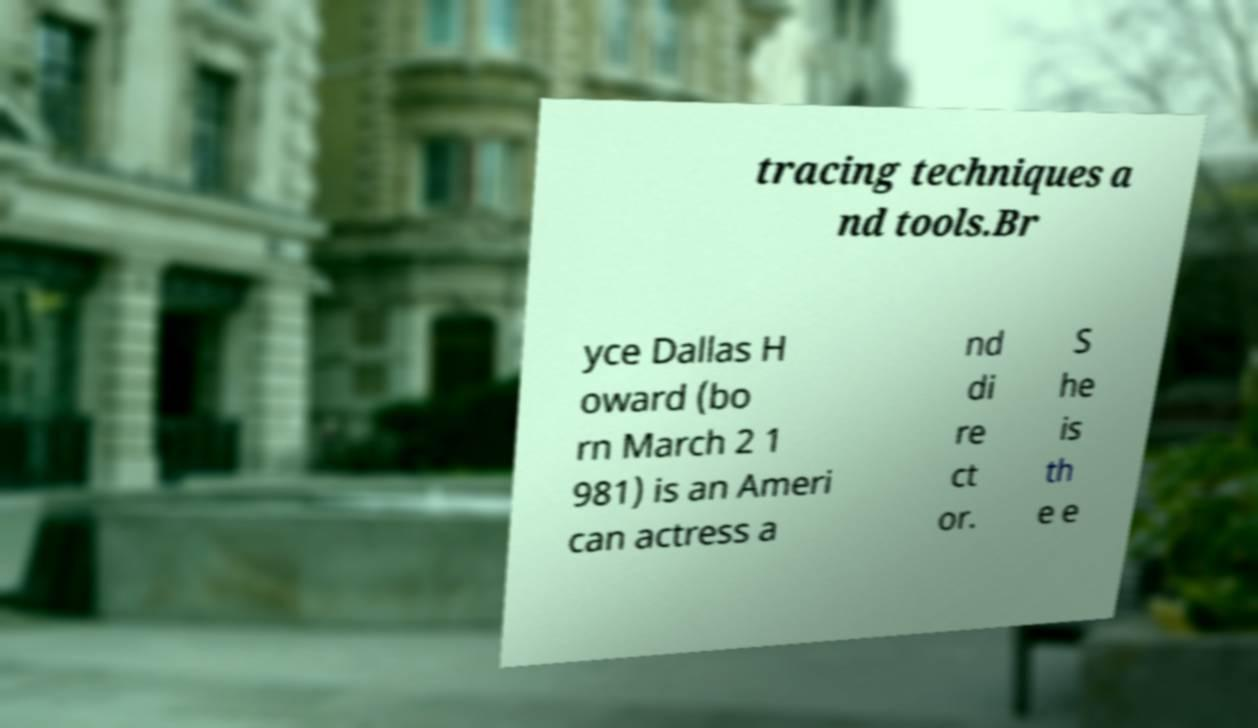Could you extract and type out the text from this image? tracing techniques a nd tools.Br yce Dallas H oward (bo rn March 2 1 981) is an Ameri can actress a nd di re ct or. S he is th e e 